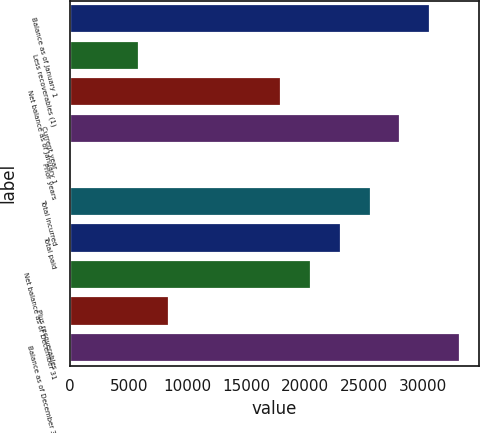Convert chart to OTSL. <chart><loc_0><loc_0><loc_500><loc_500><bar_chart><fcel>Balance as of January 1<fcel>Less recoverables (1)<fcel>Net balance as of January 1<fcel>Current year<fcel>Prior years<fcel>Total incurred<fcel>Total paid<fcel>Net balance as of December 31<fcel>Plus recoverables<fcel>Balance as of December 31<nl><fcel>30593.5<fcel>5892<fcel>17977<fcel>28070.2<fcel>17<fcel>25546.9<fcel>23023.6<fcel>20500.3<fcel>8415.3<fcel>33116.8<nl></chart> 